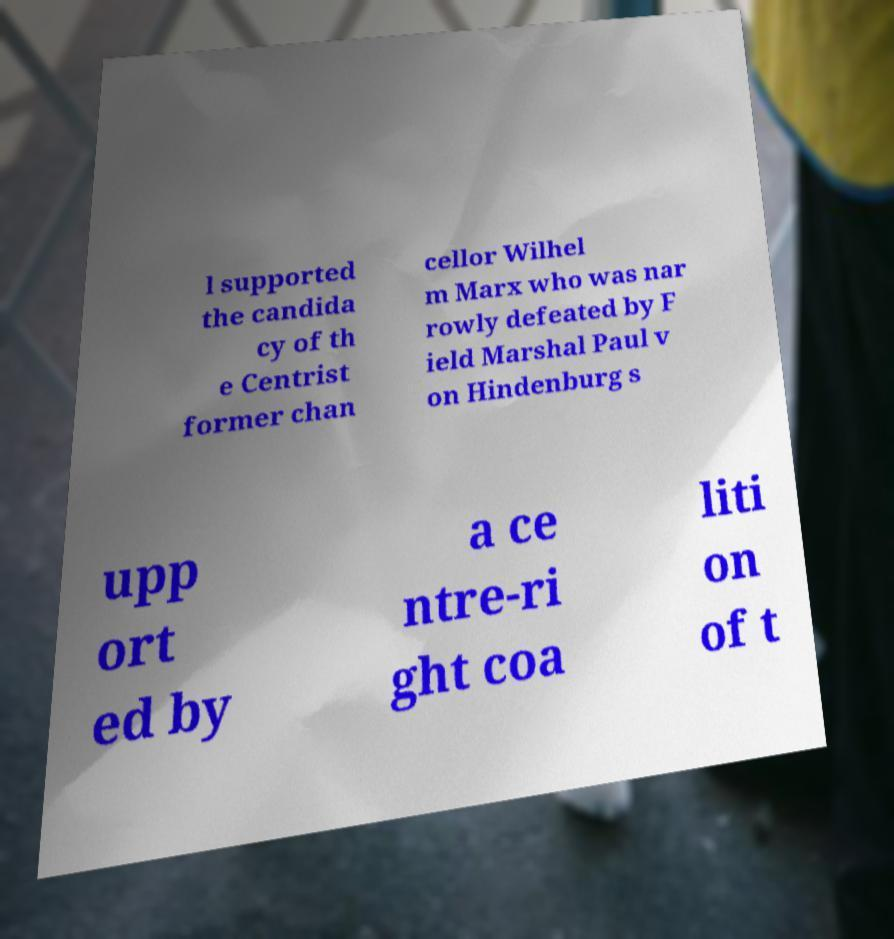There's text embedded in this image that I need extracted. Can you transcribe it verbatim? l supported the candida cy of th e Centrist former chan cellor Wilhel m Marx who was nar rowly defeated by F ield Marshal Paul v on Hindenburg s upp ort ed by a ce ntre-ri ght coa liti on of t 